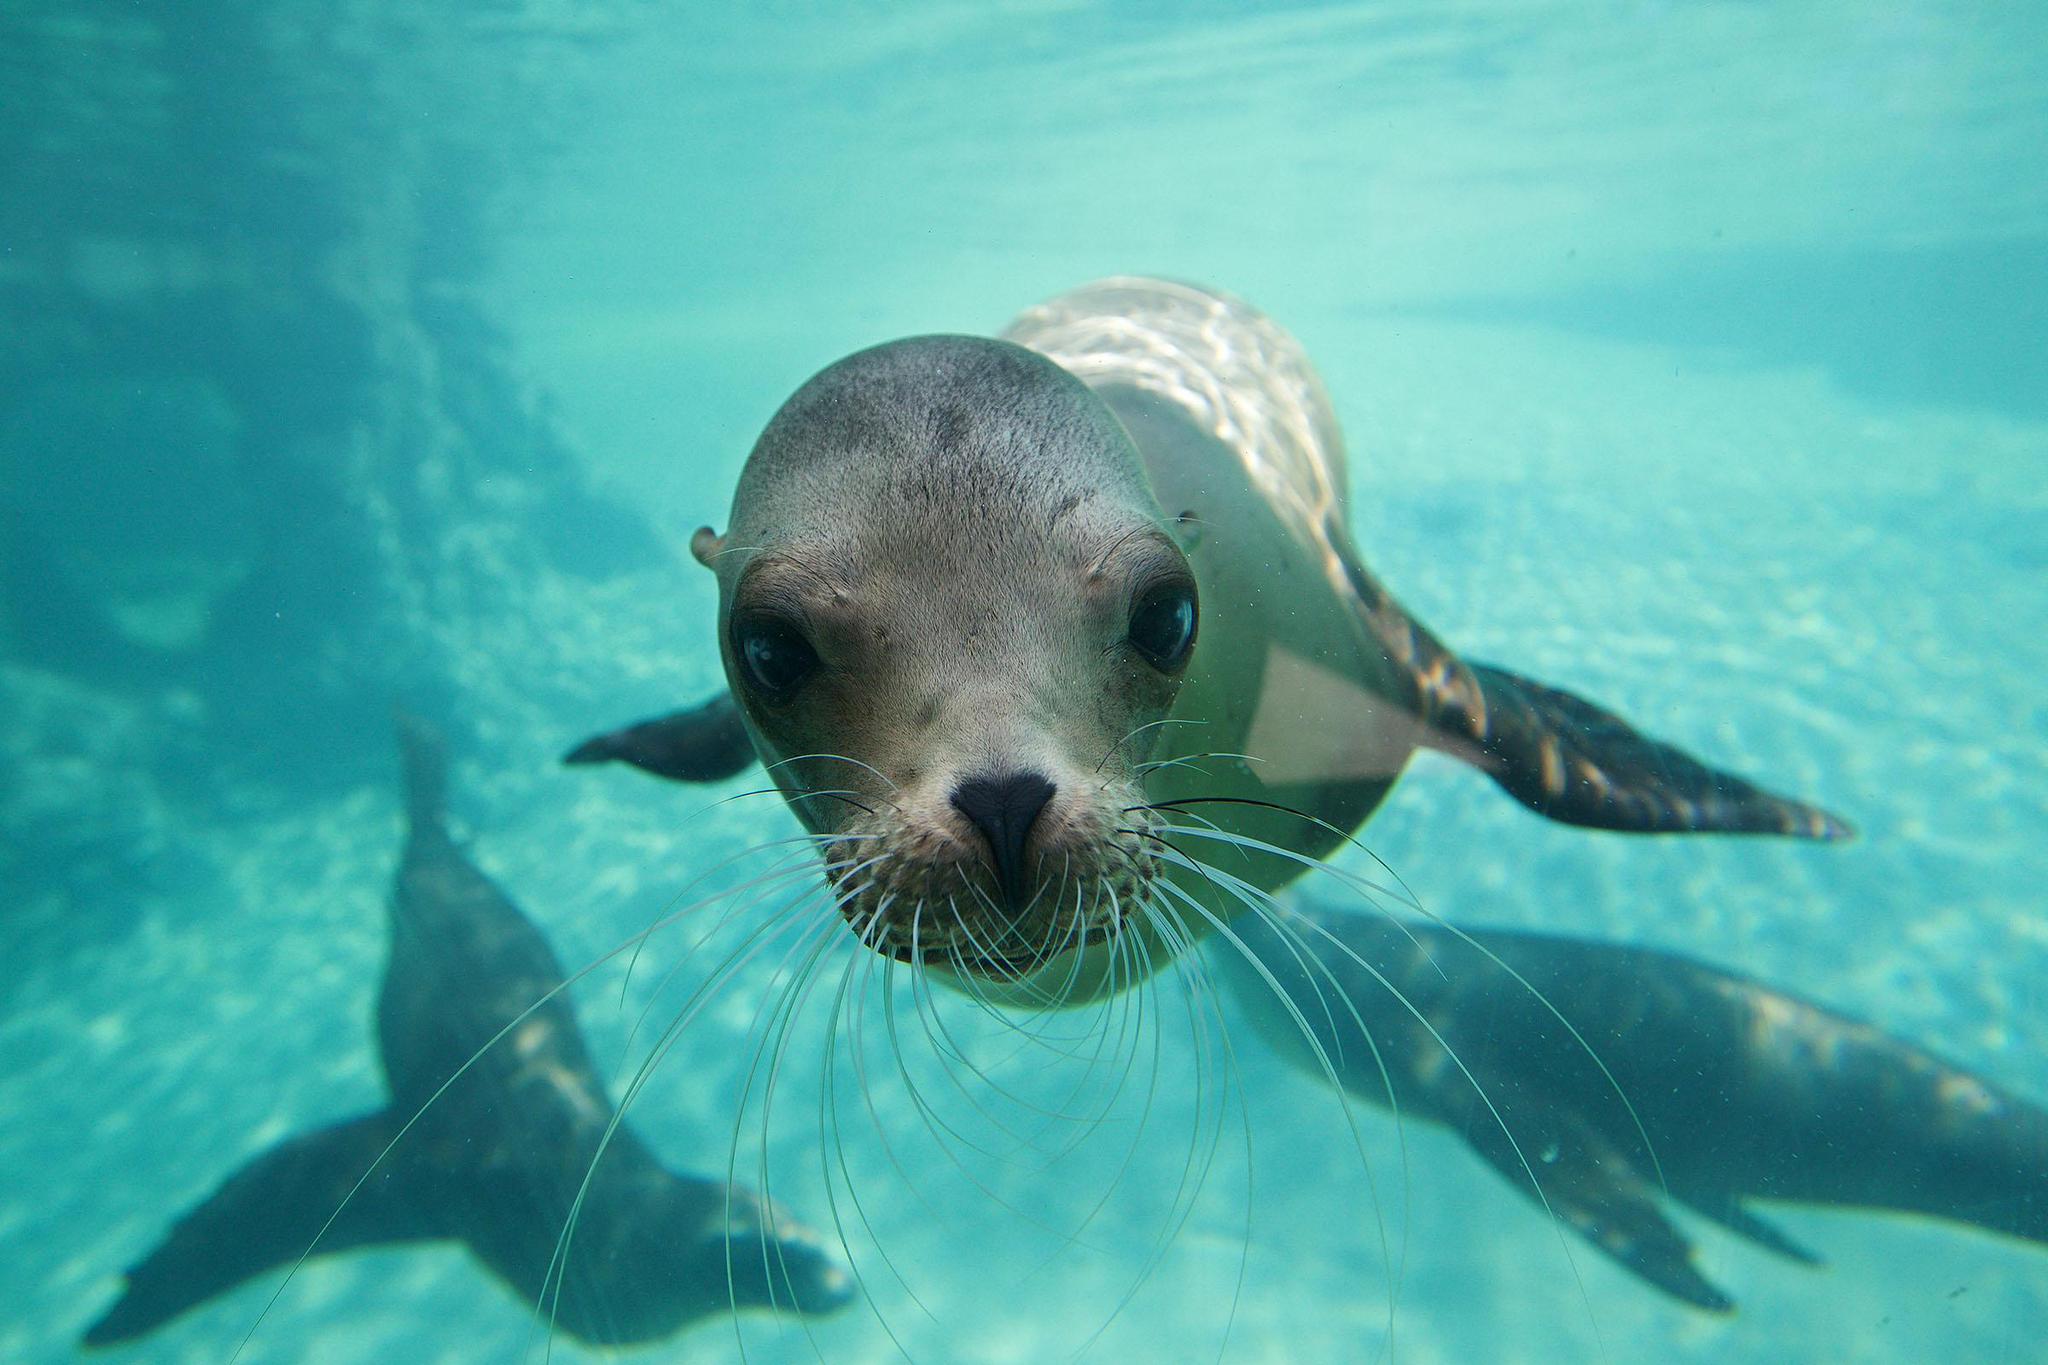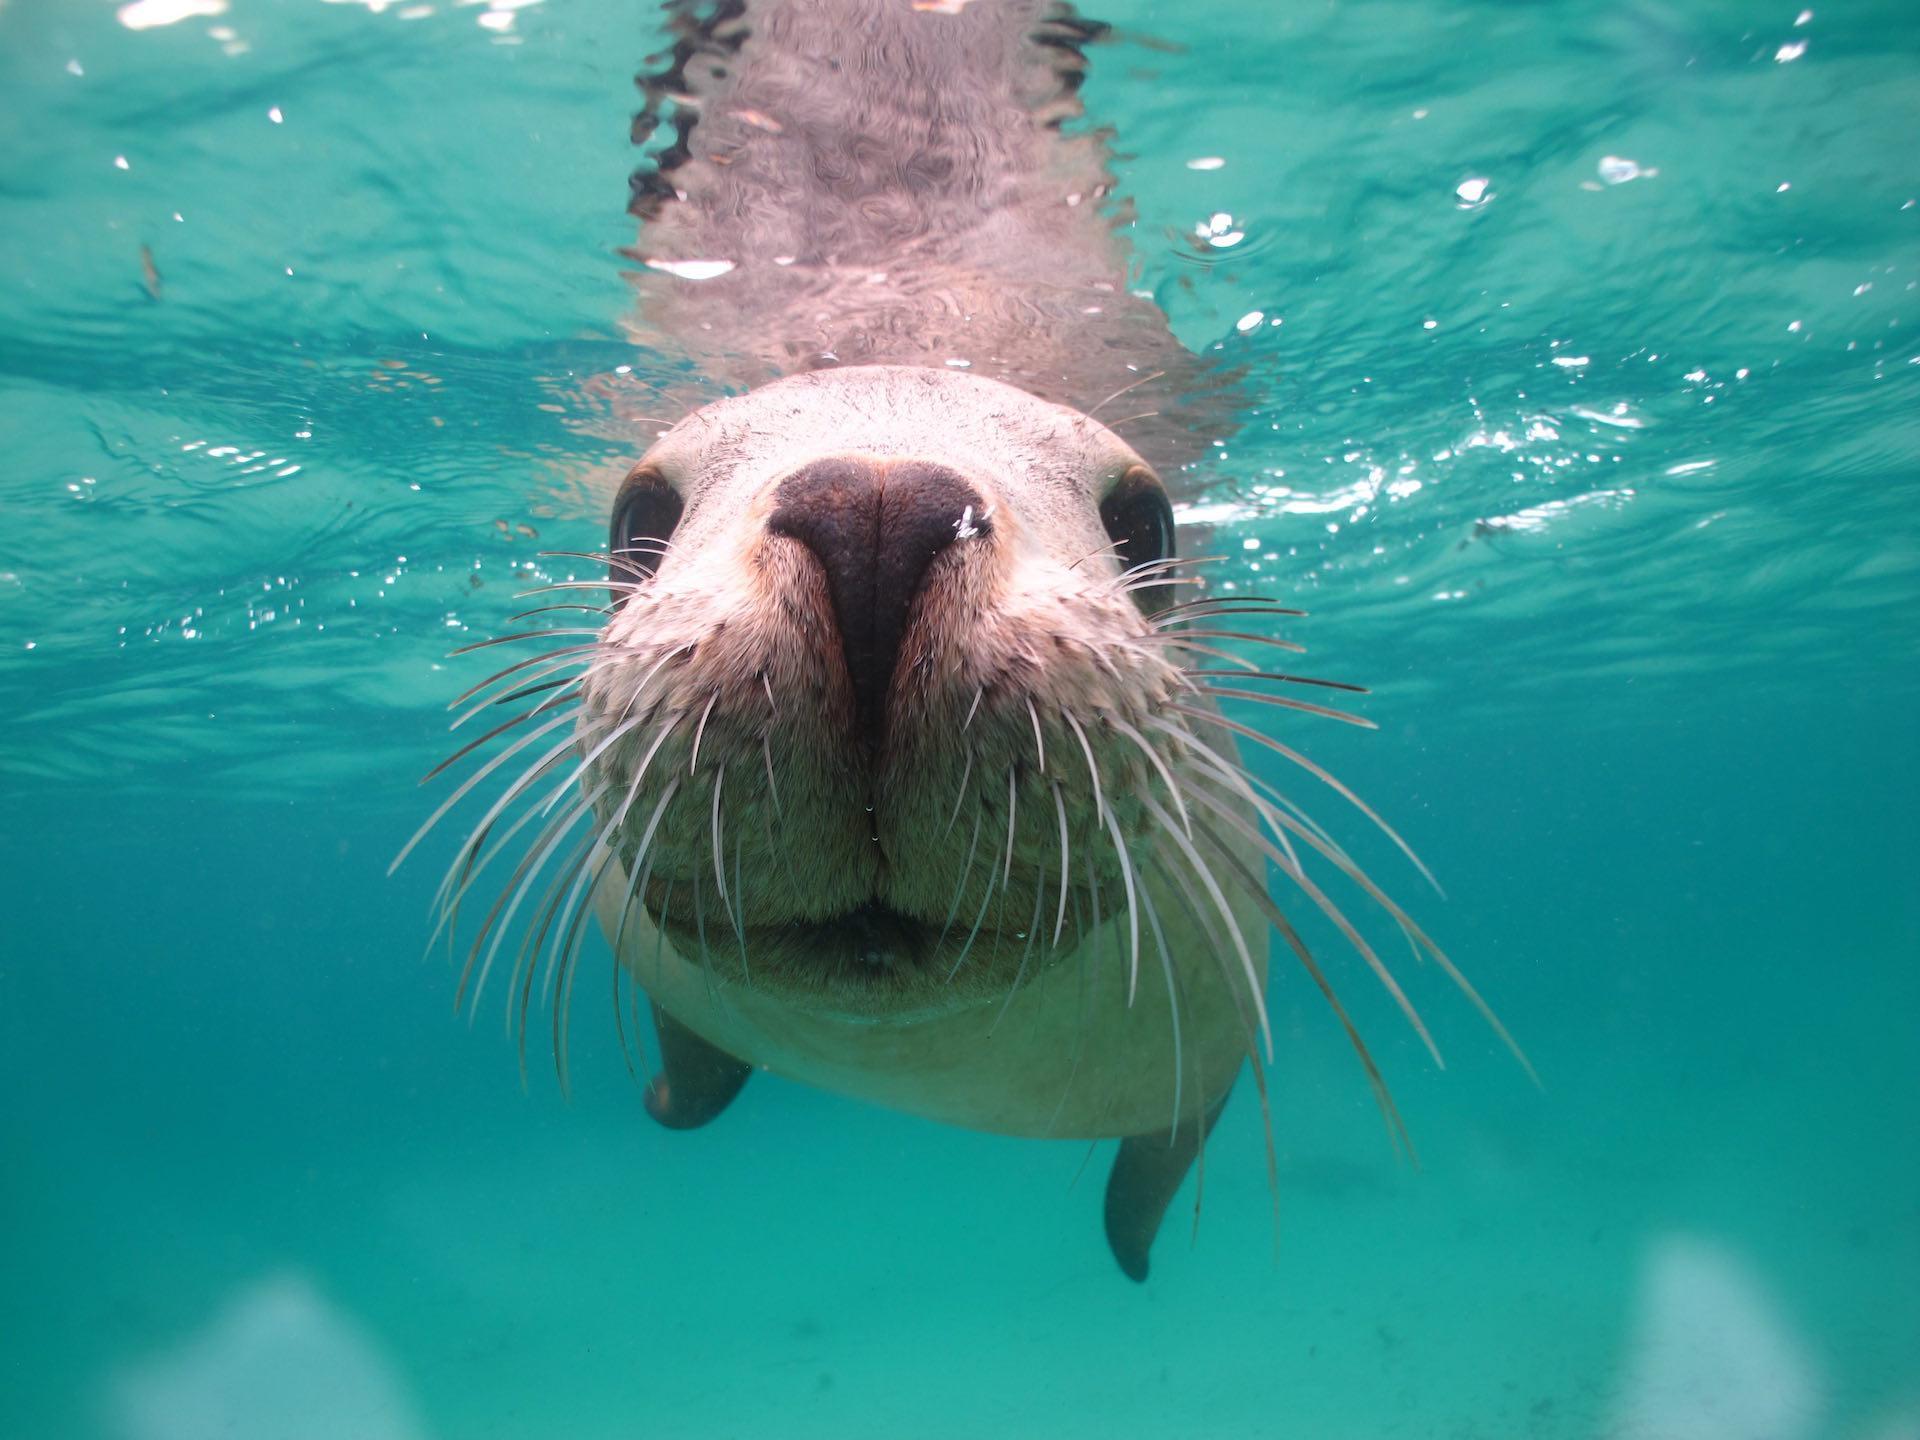The first image is the image on the left, the second image is the image on the right. For the images shown, is this caption "There are more than three seals in the water in the image on the right." true? Answer yes or no. No. The first image is the image on the left, the second image is the image on the right. Evaluate the accuracy of this statement regarding the images: "There is no more than two seals in the right image.". Is it true? Answer yes or no. Yes. 